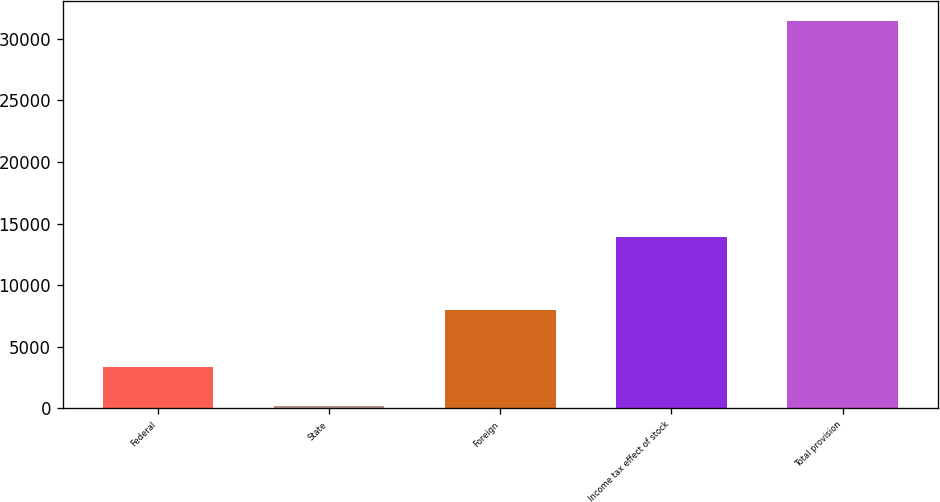<chart> <loc_0><loc_0><loc_500><loc_500><bar_chart><fcel>Federal<fcel>State<fcel>Foreign<fcel>Income tax effect of stock<fcel>Total provision<nl><fcel>3338.5<fcel>214<fcel>7985<fcel>13916<fcel>31459<nl></chart> 